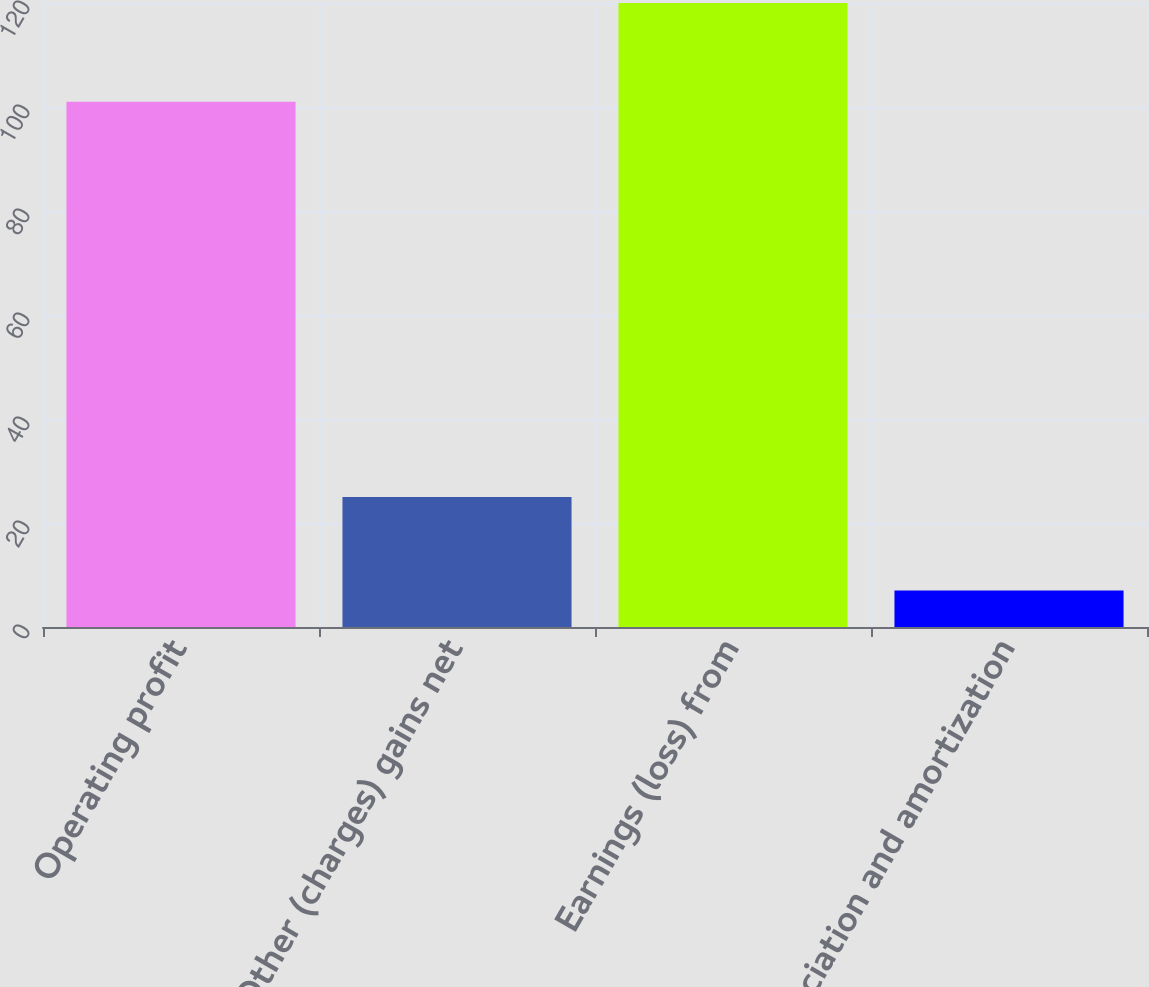Convert chart. <chart><loc_0><loc_0><loc_500><loc_500><bar_chart><fcel>Operating profit<fcel>Other (charges) gains net<fcel>Earnings (loss) from<fcel>Depreciation and amortization<nl><fcel>101<fcel>25<fcel>120<fcel>7<nl></chart> 